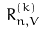<formula> <loc_0><loc_0><loc_500><loc_500>R _ { n , V } ^ { ( k ) }</formula> 